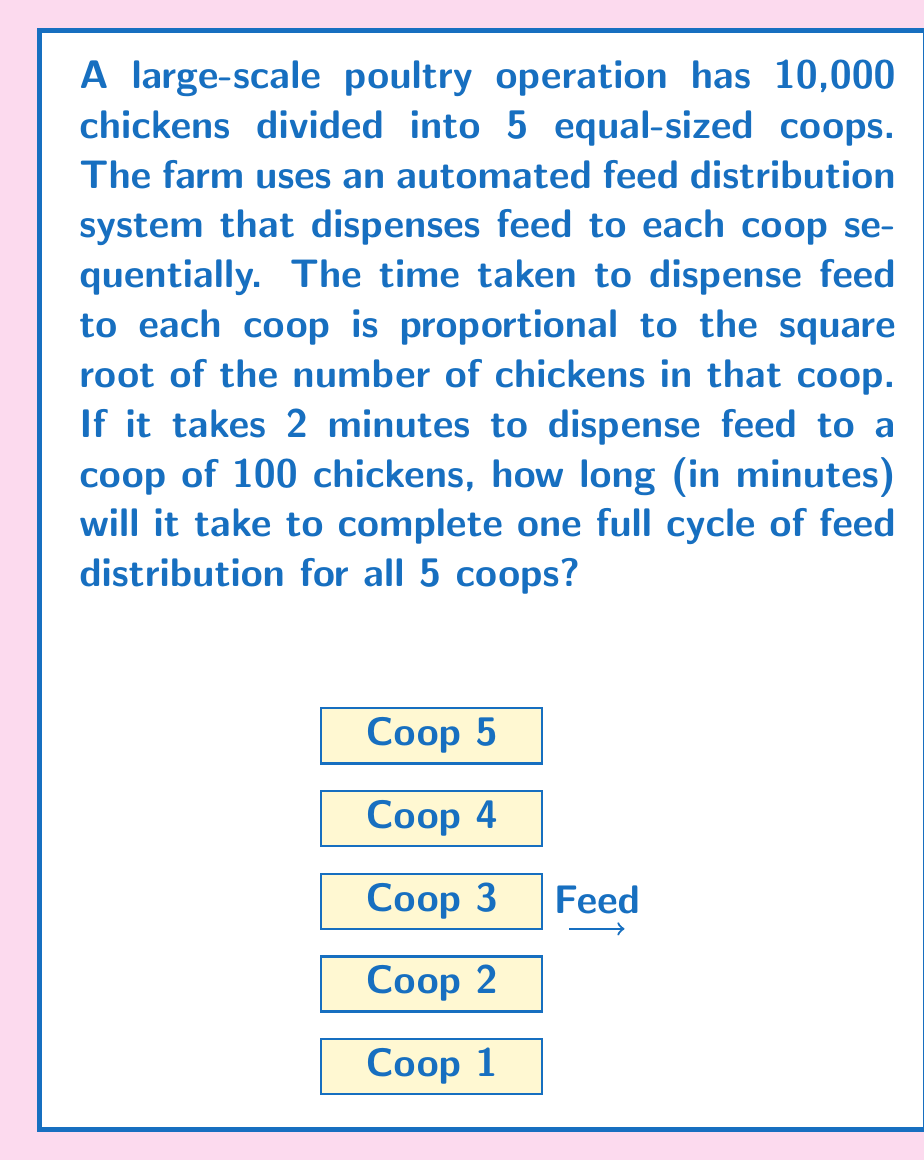Help me with this question. Let's approach this step-by-step:

1) First, we need to determine how many chickens are in each coop:
   Total chickens = 10,000
   Number of coops = 5
   Chickens per coop = 10,000 / 5 = 2,000

2) We're told that the time to dispense feed is proportional to the square root of the number of chickens. Let's express this mathematically:

   $T \propto \sqrt{N}$, where T is time and N is number of chickens

3) We're given a reference point: 2 minutes for 100 chickens. Let's use this to find the constant of proportionality (k):

   $2 = k\sqrt{100}$
   $2 = 10k$
   $k = 0.2$

4) Now we can create our equation:

   $T = 0.2\sqrt{N}$

5) For each coop with 2,000 chickens:

   $T = 0.2\sqrt{2000} = 0.2 * \sqrt{2} * \sqrt{1000} \approx 8.94$ minutes

6) Since there are 5 identical coops, we multiply this time by 5:

   Total time = $5 * 8.94 = 44.7$ minutes

Therefore, it will take approximately 44.7 minutes to complete one full cycle of feed distribution for all 5 coops.
Answer: 44.7 minutes 